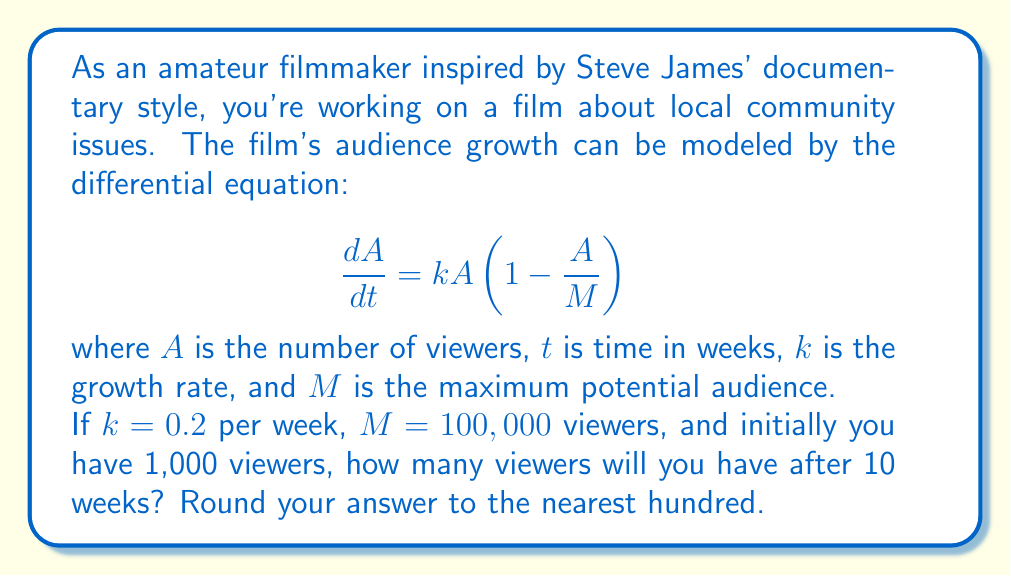Show me your answer to this math problem. Let's solve this step-by-step:

1) The given differential equation is a logistic growth model:
   $$\frac{dA}{dt} = kA(1-\frac{A}{M})$$

2) The solution to this equation is:
   $$A(t) = \frac{M}{1 + (\frac{M}{A_0} - 1)e^{-kt}}$$
   where $A_0$ is the initial number of viewers.

3) We're given:
   $k = 0.2$ per week
   $M = 100,000$ viewers
   $A_0 = 1,000$ viewers
   $t = 10$ weeks

4) Let's substitute these values into our solution:
   $$A(10) = \frac{100,000}{1 + (\frac{100,000}{1,000} - 1)e^{-0.2 * 10}}$$

5) Simplify:
   $$A(10) = \frac{100,000}{1 + 99e^{-2}}$$

6) Calculate:
   $$A(10) = \frac{100,000}{1 + 99 * 0.1353}$$
   $$A(10) = \frac{100,000}{14.3947}$$
   $$A(10) = 6,947.26$$

7) Rounding to the nearest hundred:
   $A(10) \approx 6,900$ viewers
Answer: 6,900 viewers 